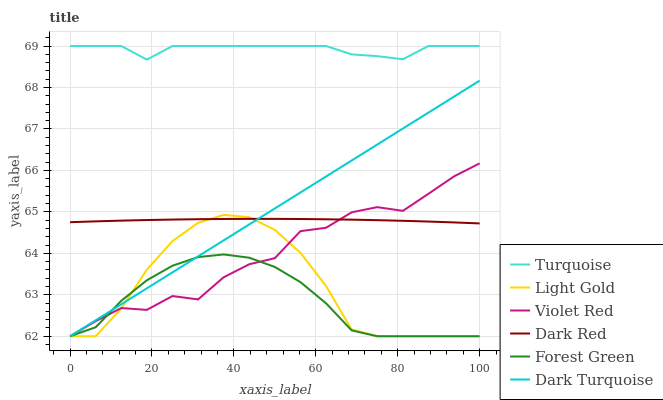Does Dark Red have the minimum area under the curve?
Answer yes or no. No. Does Dark Red have the maximum area under the curve?
Answer yes or no. No. Is Dark Red the smoothest?
Answer yes or no. No. Is Dark Red the roughest?
Answer yes or no. No. Does Dark Red have the lowest value?
Answer yes or no. No. Does Dark Red have the highest value?
Answer yes or no. No. Is Forest Green less than Turquoise?
Answer yes or no. Yes. Is Turquoise greater than Dark Turquoise?
Answer yes or no. Yes. Does Forest Green intersect Turquoise?
Answer yes or no. No. 